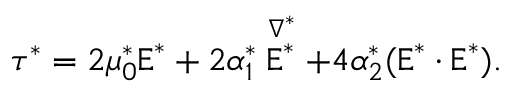Convert formula to latex. <formula><loc_0><loc_0><loc_500><loc_500>\tau ^ { * } = 2 \mu _ { 0 } ^ { * } E ^ { * } + 2 \alpha _ { 1 } ^ { * } \stackrel { \nabla ^ { * } } { E ^ { * } } + 4 \alpha _ { 2 } ^ { * } ( E ^ { * } \cdot E ^ { * } ) .</formula> 